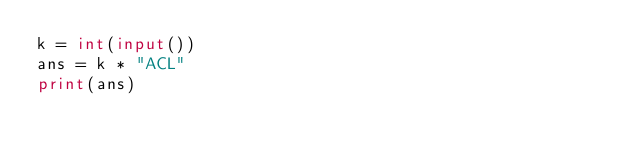<code> <loc_0><loc_0><loc_500><loc_500><_Python_>k = int(input())
ans = k * "ACL"
print(ans)</code> 